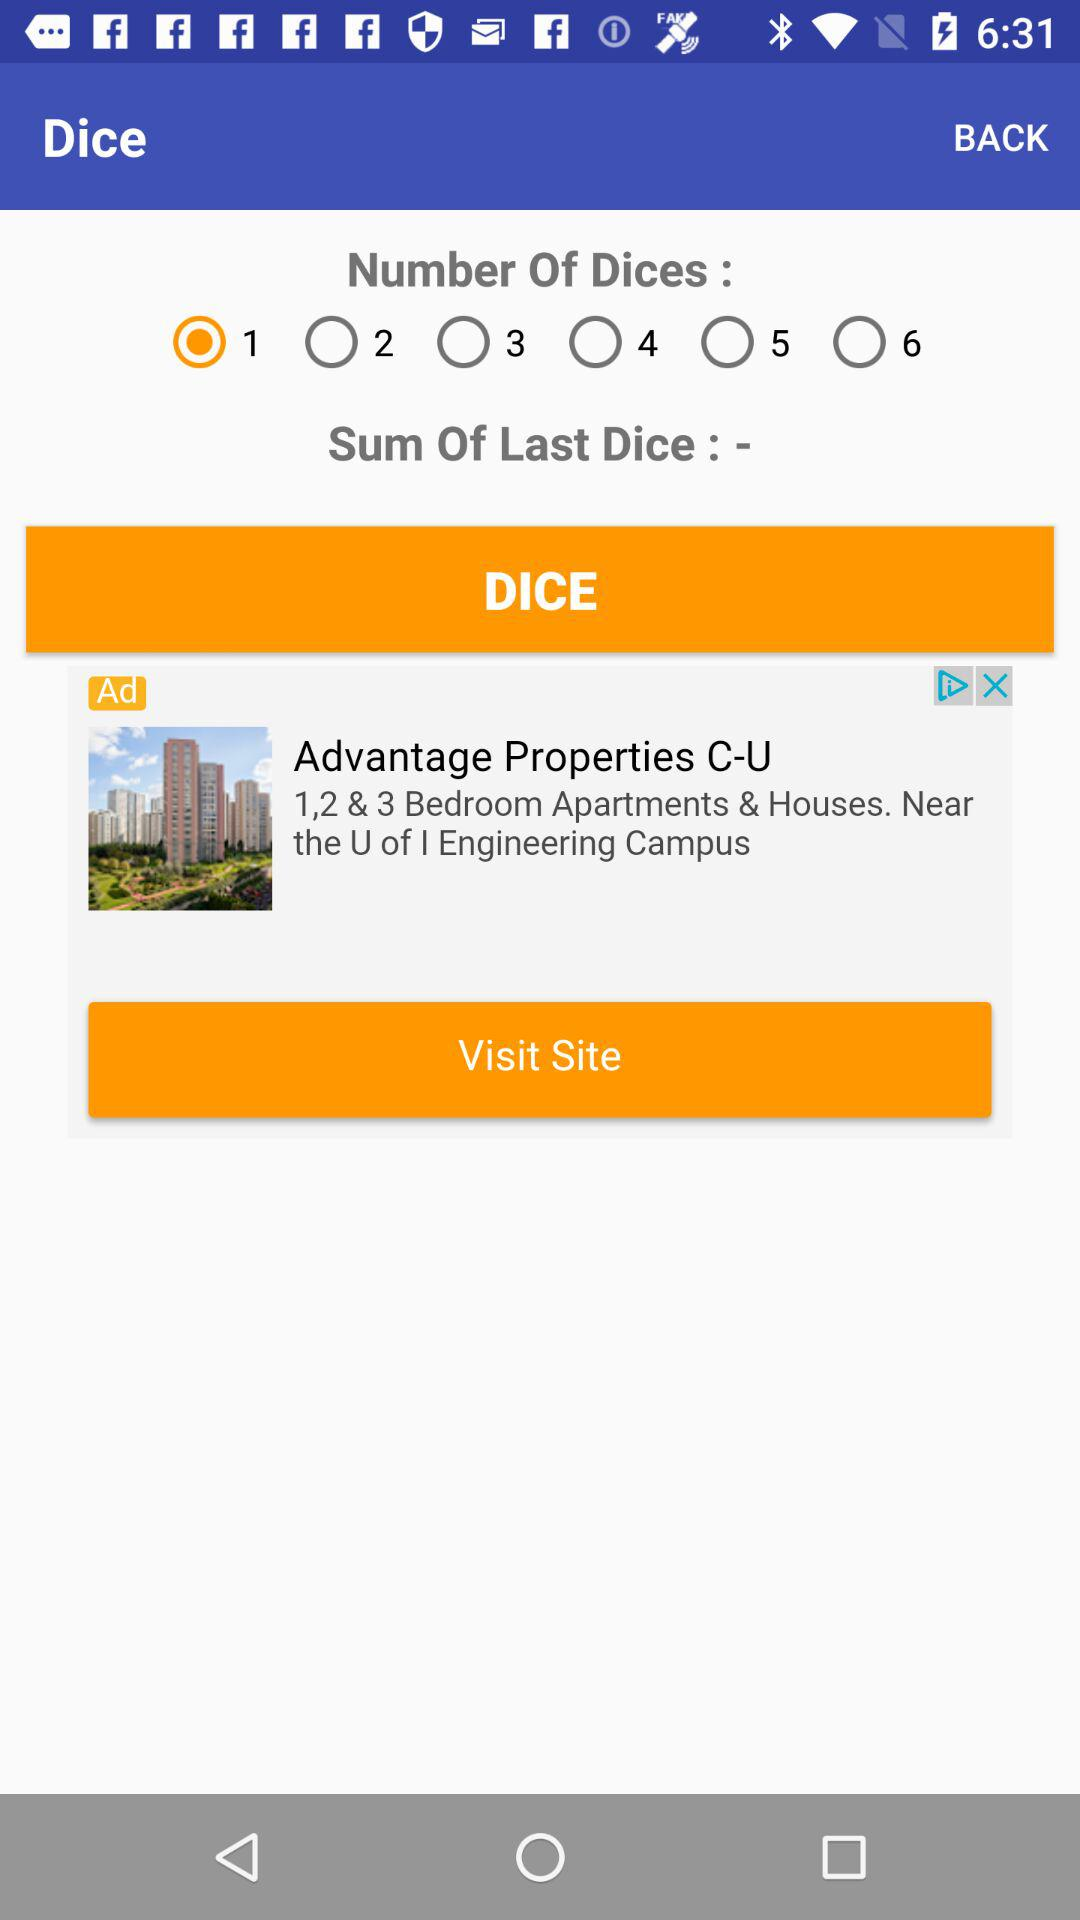What is the name of the application?
When the provided information is insufficient, respond with <no answer>. <no answer> 